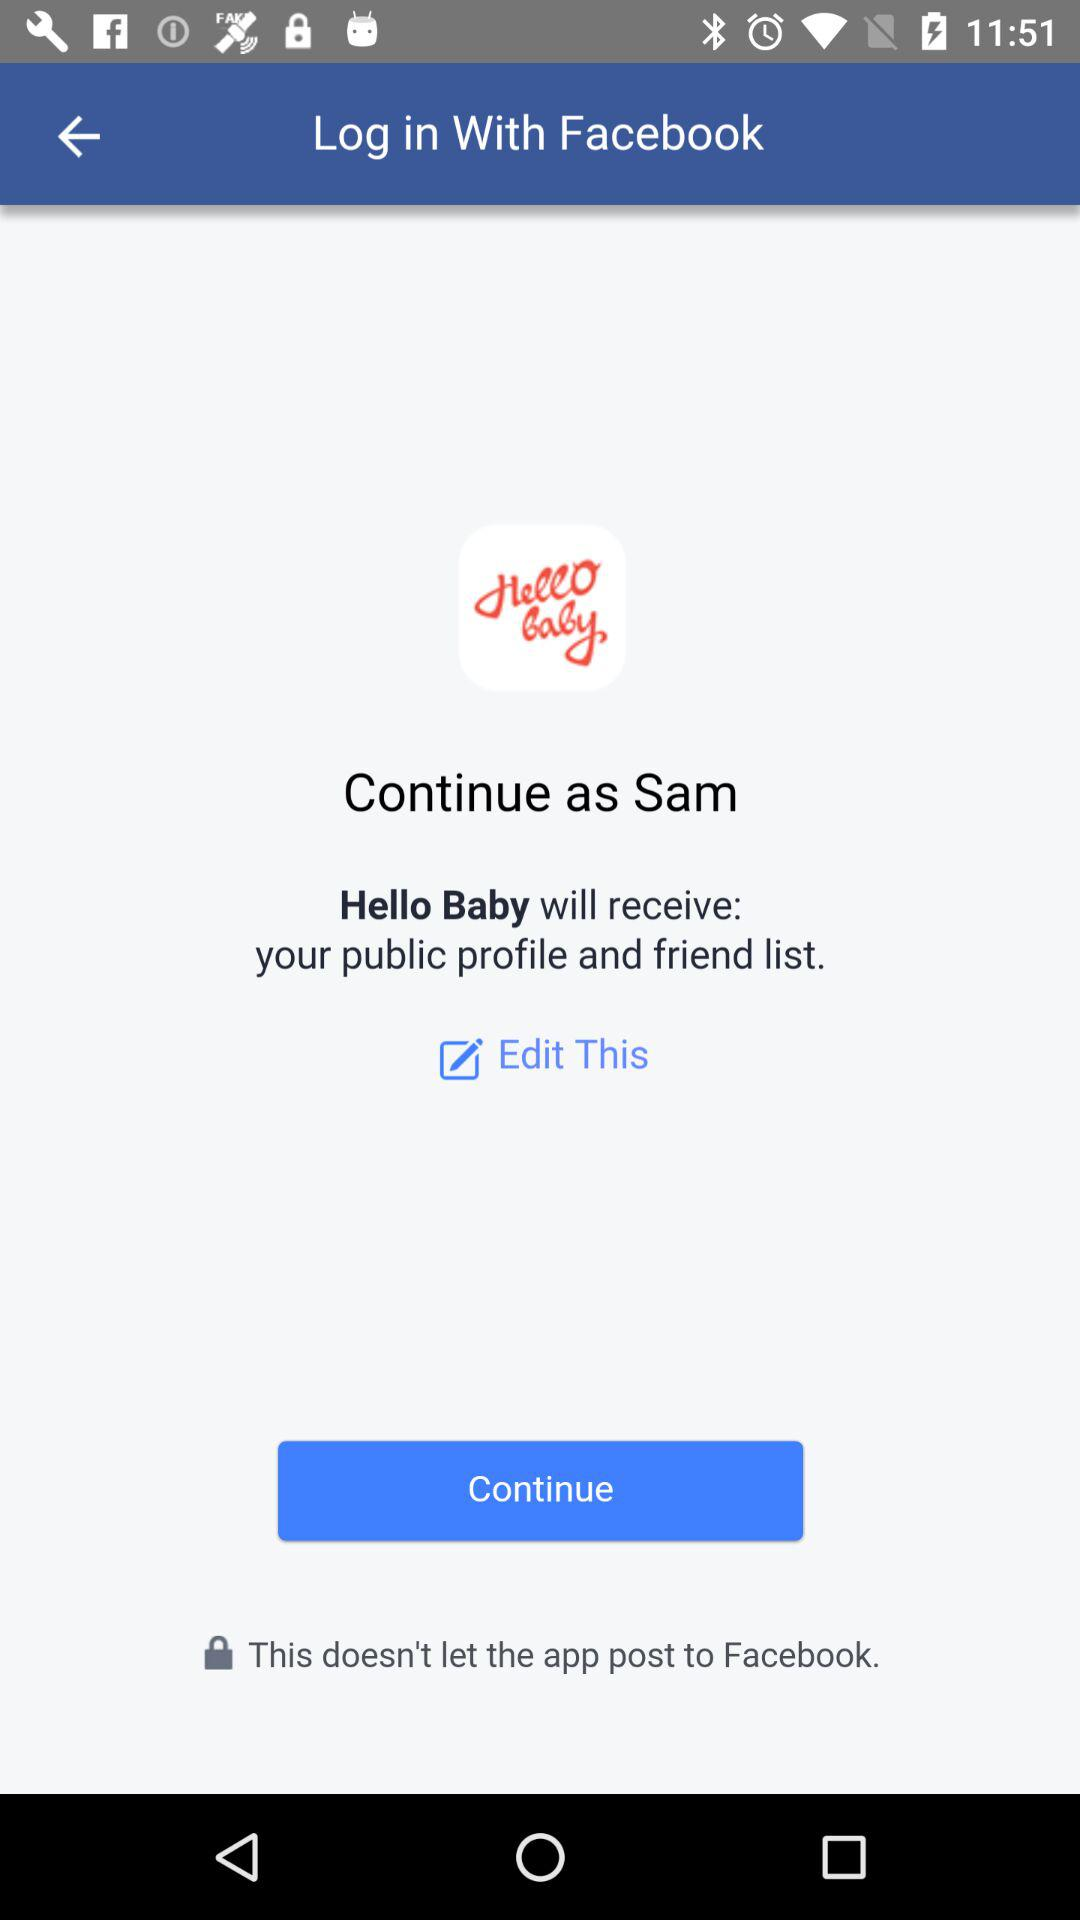Who will receive the public profile and friend list? The application that will receive the public profile and friend list is "Hello Baby". 